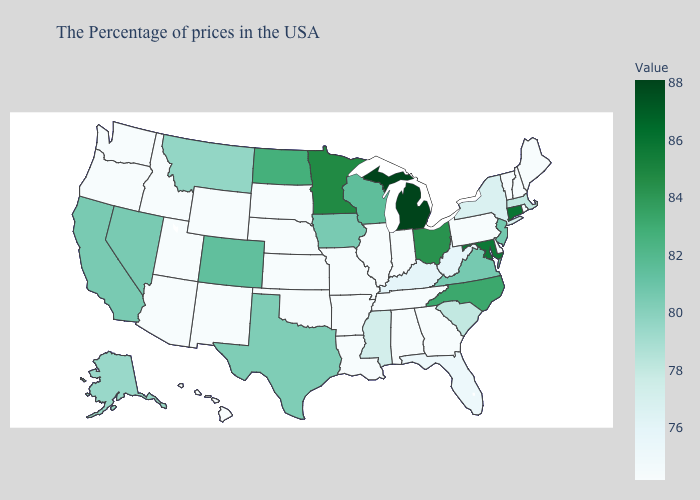Is the legend a continuous bar?
Short answer required. Yes. Which states have the lowest value in the USA?
Write a very short answer. Maine, Rhode Island, New Hampshire, Vermont, Delaware, Pennsylvania, Georgia, Indiana, Alabama, Tennessee, Illinois, Louisiana, Missouri, Arkansas, Kansas, Nebraska, Oklahoma, South Dakota, Wyoming, New Mexico, Utah, Arizona, Idaho, Washington, Oregon, Hawaii. Among the states that border Alabama , which have the lowest value?
Concise answer only. Georgia, Tennessee. Which states have the lowest value in the USA?
Quick response, please. Maine, Rhode Island, New Hampshire, Vermont, Delaware, Pennsylvania, Georgia, Indiana, Alabama, Tennessee, Illinois, Louisiana, Missouri, Arkansas, Kansas, Nebraska, Oklahoma, South Dakota, Wyoming, New Mexico, Utah, Arizona, Idaho, Washington, Oregon, Hawaii. Does Mississippi have a higher value than Louisiana?
Give a very brief answer. Yes. 